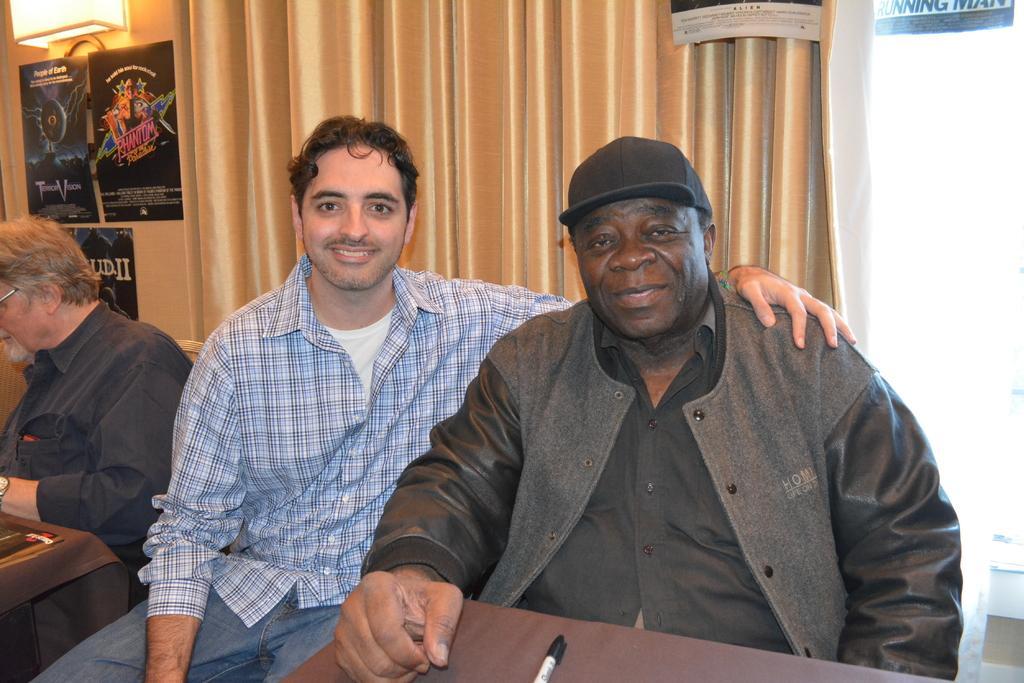Describe this image in one or two sentences. In this image we can see persons sitting at the table. On the table we can see marker. In the background we can see certain, posts, light and wall. 